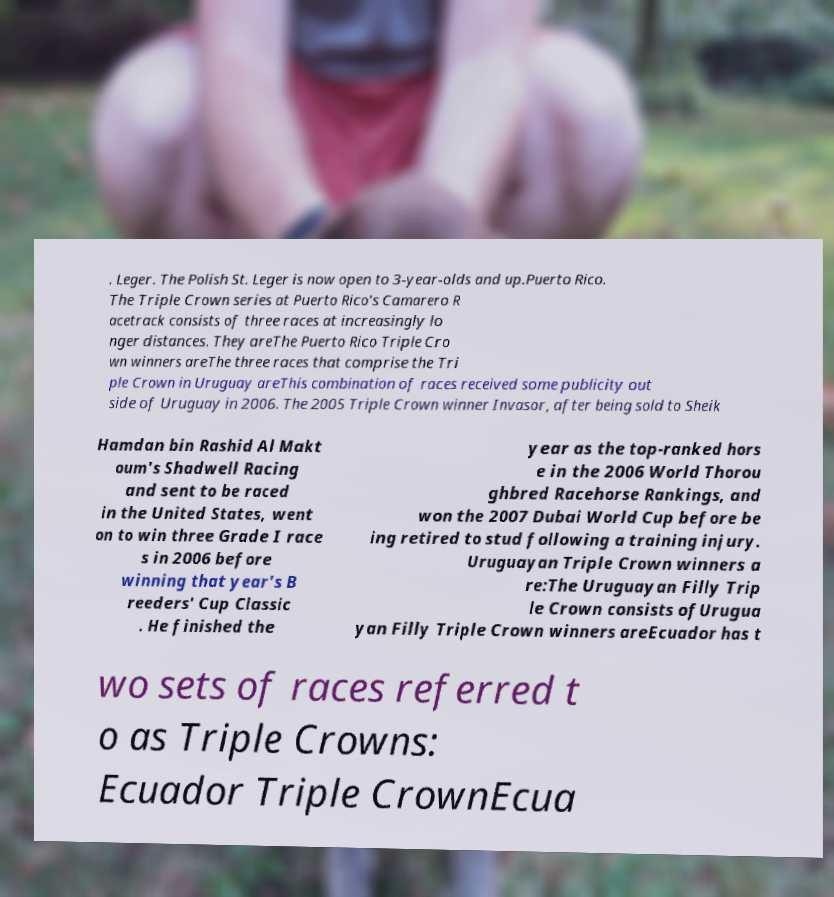What messages or text are displayed in this image? I need them in a readable, typed format. . Leger. The Polish St. Leger is now open to 3-year-olds and up.Puerto Rico. The Triple Crown series at Puerto Rico's Camarero R acetrack consists of three races at increasingly lo nger distances. They areThe Puerto Rico Triple Cro wn winners areThe three races that comprise the Tri ple Crown in Uruguay areThis combination of races received some publicity out side of Uruguay in 2006. The 2005 Triple Crown winner Invasor, after being sold to Sheik Hamdan bin Rashid Al Makt oum's Shadwell Racing and sent to be raced in the United States, went on to win three Grade I race s in 2006 before winning that year's B reeders' Cup Classic . He finished the year as the top-ranked hors e in the 2006 World Thorou ghbred Racehorse Rankings, and won the 2007 Dubai World Cup before be ing retired to stud following a training injury. Uruguayan Triple Crown winners a re:The Uruguayan Filly Trip le Crown consists ofUrugua yan Filly Triple Crown winners areEcuador has t wo sets of races referred t o as Triple Crowns: Ecuador Triple CrownEcua 